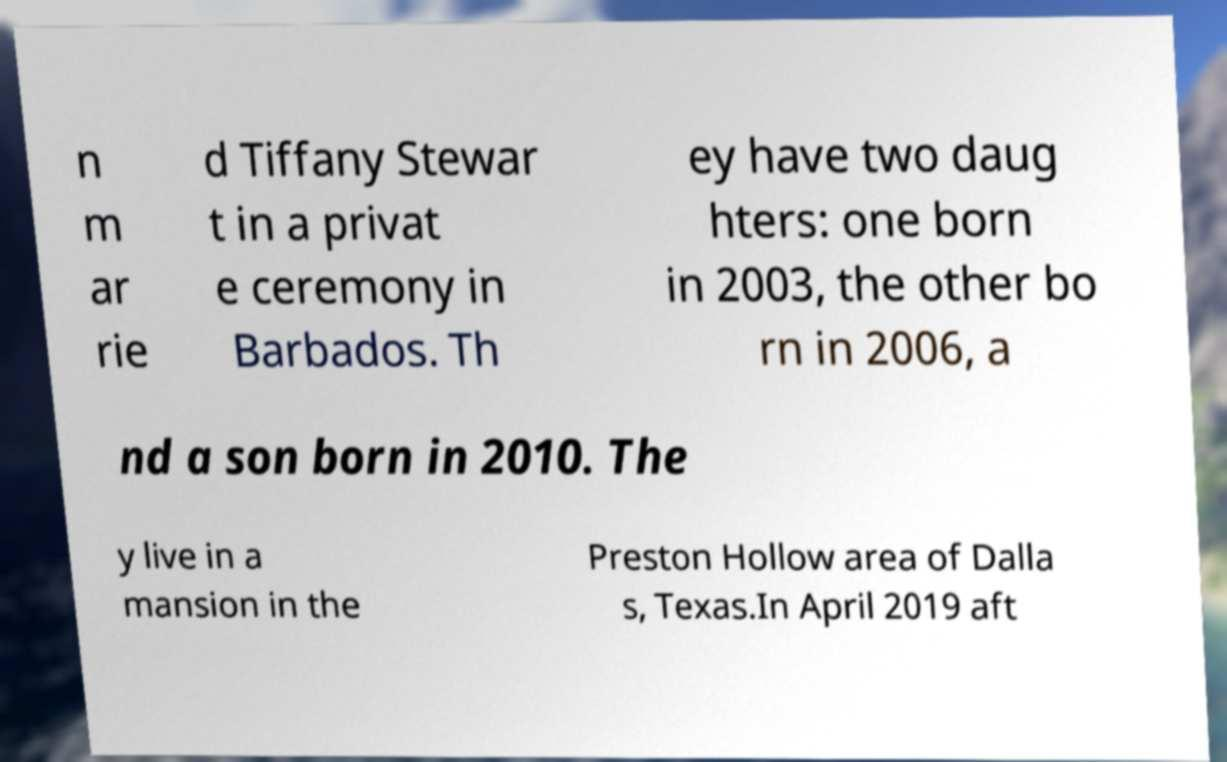Please read and relay the text visible in this image. What does it say? n m ar rie d Tiffany Stewar t in a privat e ceremony in Barbados. Th ey have two daug hters: one born in 2003, the other bo rn in 2006, a nd a son born in 2010. The y live in a mansion in the Preston Hollow area of Dalla s, Texas.In April 2019 aft 